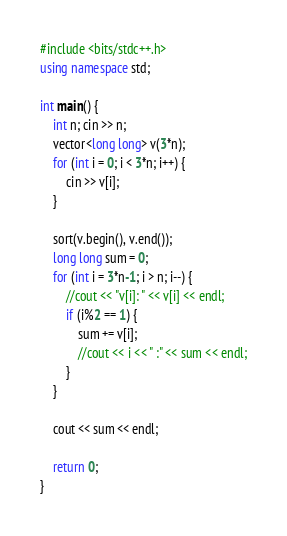<code> <loc_0><loc_0><loc_500><loc_500><_C++_>#include <bits/stdc++.h>
using namespace std;

int main() {
    int n; cin >> n;
    vector<long long> v(3*n);
    for (int i = 0; i < 3*n; i++) {
        cin >> v[i];
    }

    sort(v.begin(), v.end());
    long long sum = 0;
    for (int i = 3*n-1; i > n; i--) {
        //cout << "v[i]: " << v[i] << endl;
        if (i%2 == 1) {
            sum += v[i];
            //cout << i << " :" << sum << endl;
        }
    }

    cout << sum << endl;

    return 0;
}</code> 